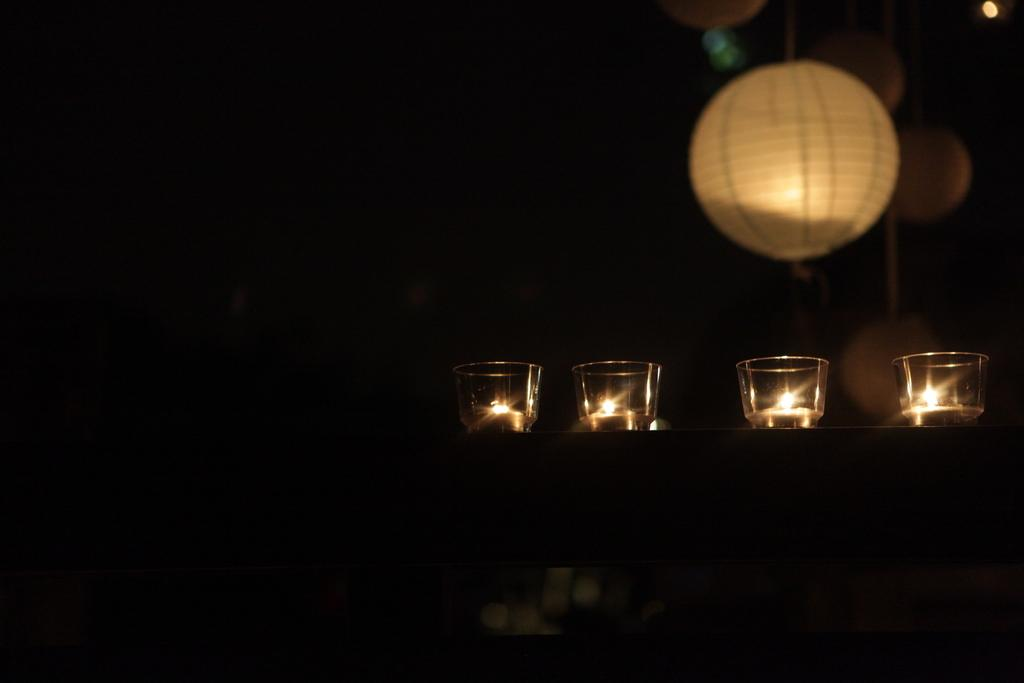What objects are inside the glass in the image? There are candles in the glass in the image. What color is the background of the image? The background of the image is black. What type of selection is being made by the snails in the image? There are no snails present in the image, so it is not possible to determine if they are making any selections. 